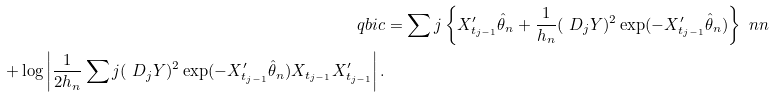Convert formula to latex. <formula><loc_0><loc_0><loc_500><loc_500>\ q b i c & = \sum j \left \{ X _ { t _ { j - 1 } } ^ { \prime } \hat { \theta } _ { n } + \frac { 1 } { h _ { n } } ( \ D _ { j } Y ) ^ { 2 } \exp ( - X _ { t _ { j - 1 } } ^ { \prime } \hat { \theta } _ { n } ) \right \} \ n n \\ \quad + \log \left | \frac { 1 } { 2 h _ { n } } \sum j ( \ D _ { j } Y ) ^ { 2 } \exp ( - X _ { t _ { j - 1 } } ^ { \prime } \hat { \theta } _ { n } ) X _ { t _ { j - 1 } } X _ { t _ { j - 1 } } ^ { \prime } \right | .</formula> 